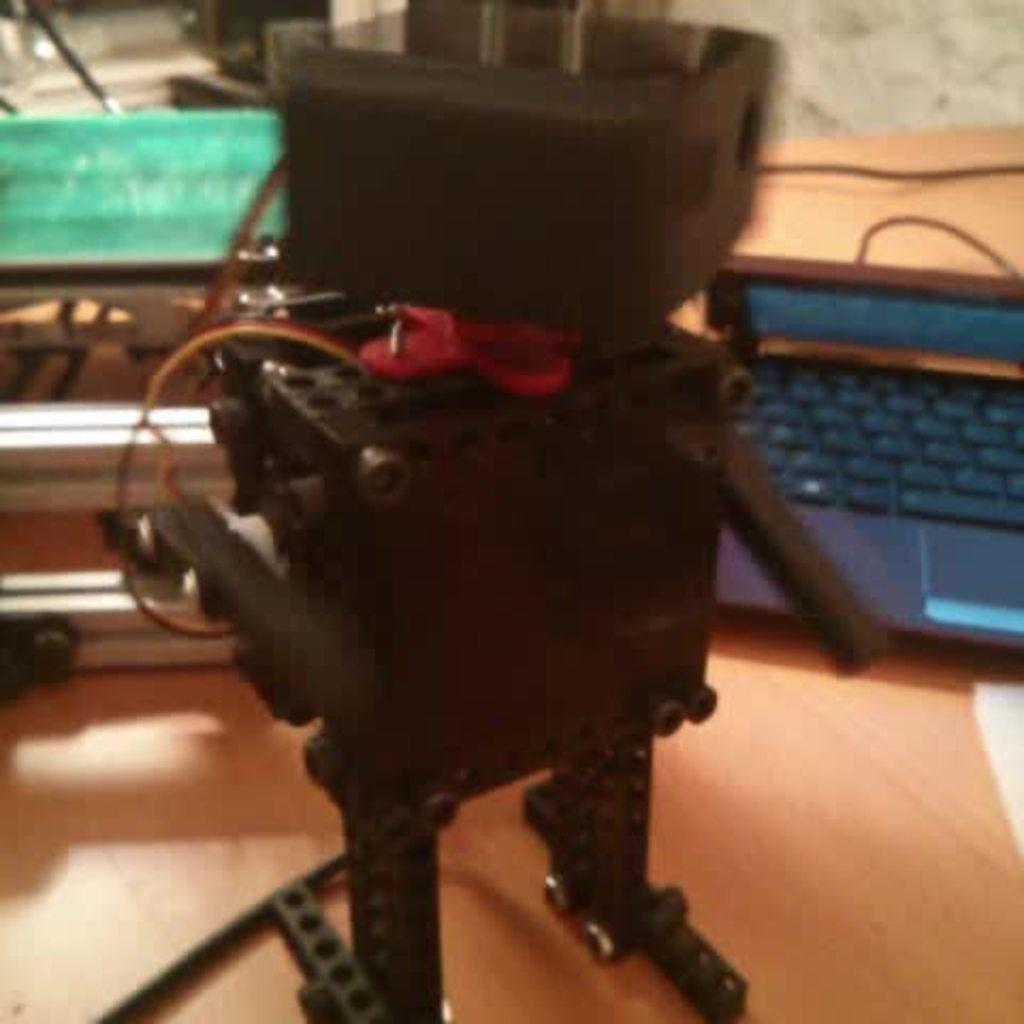What is the main subject on the table in the image? There is a robot on the table in the image. What electronic device can be seen in the image? There is a laptop in the image. Can you describe the objects behind the robot and laptop? Unfortunately, the provided facts do not specify the nature of the objects behind the robot and laptop. How many baskets are hanging on the wall behind the robot and laptop? There is no mention of baskets in the image, so we cannot determine their presence or quantity. 